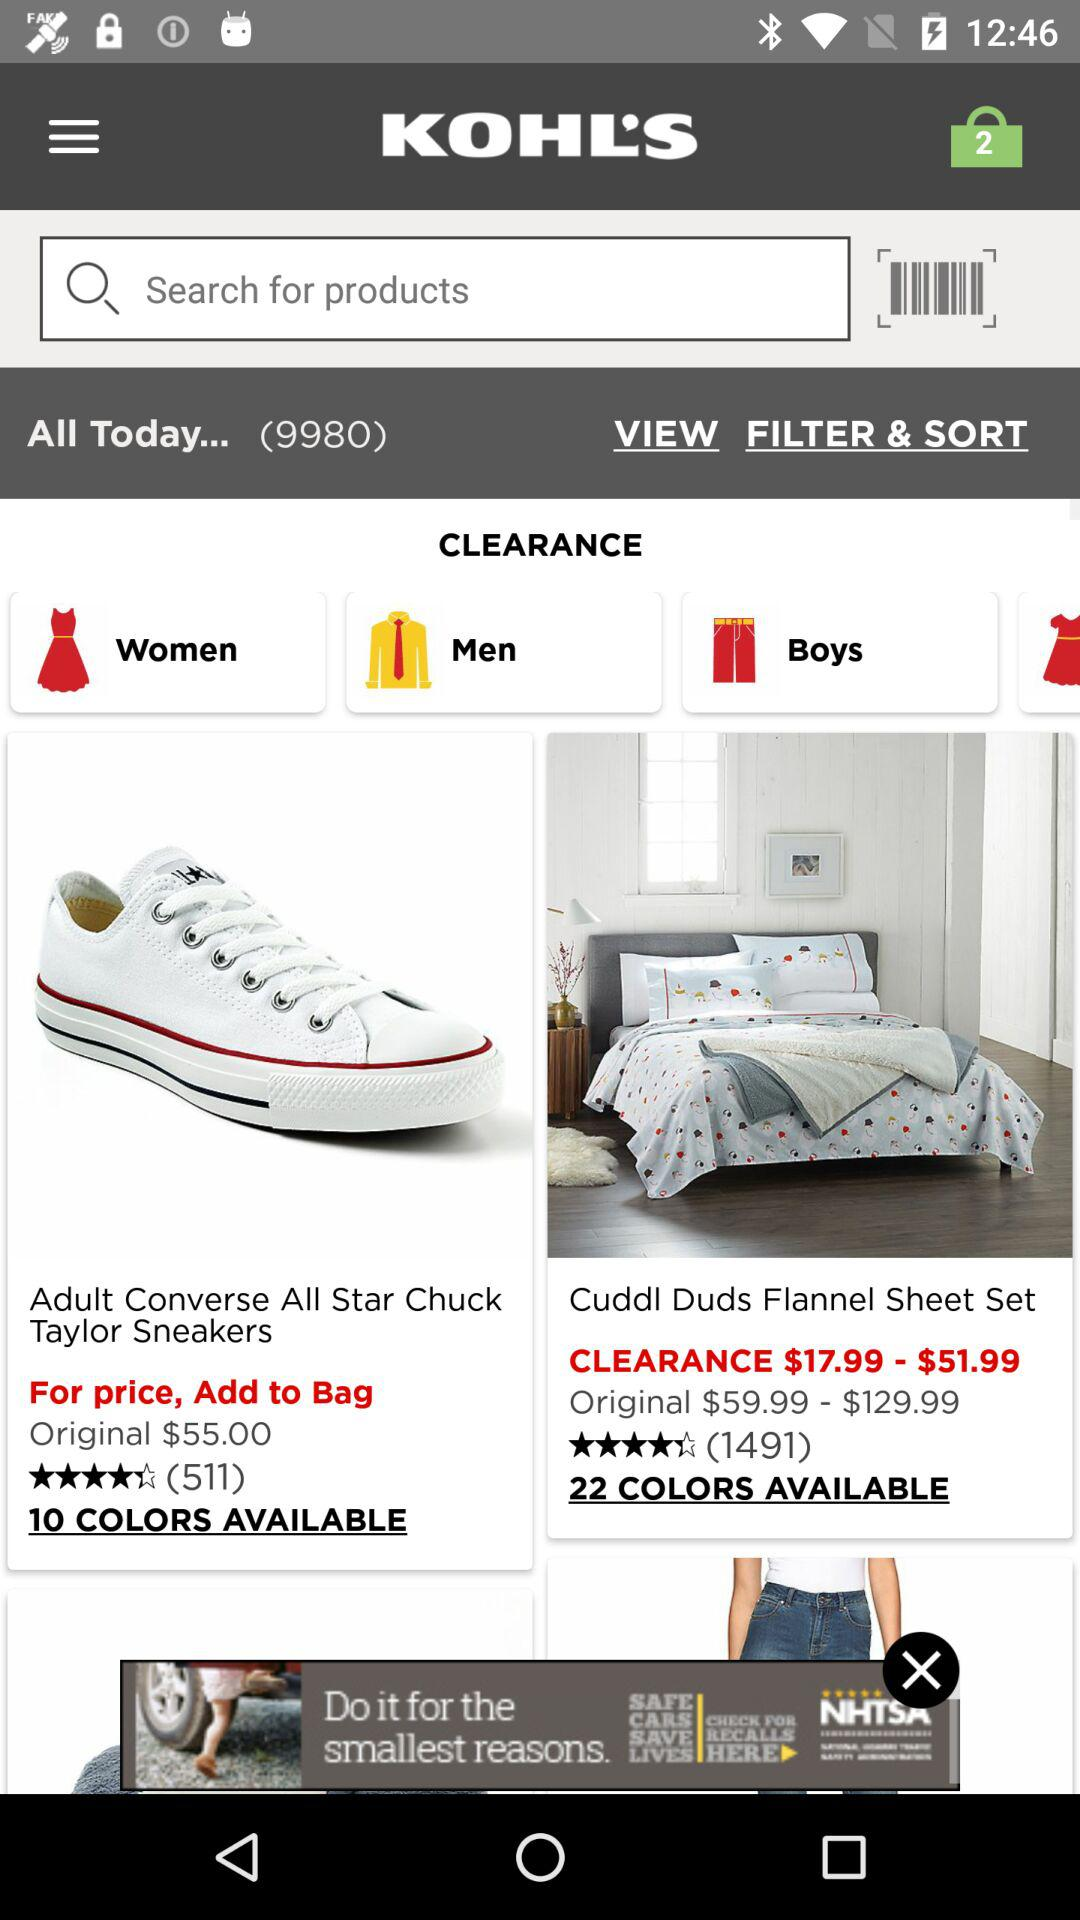How many colors are available for sheet sets? There are 22 colors available for sheet sets. 